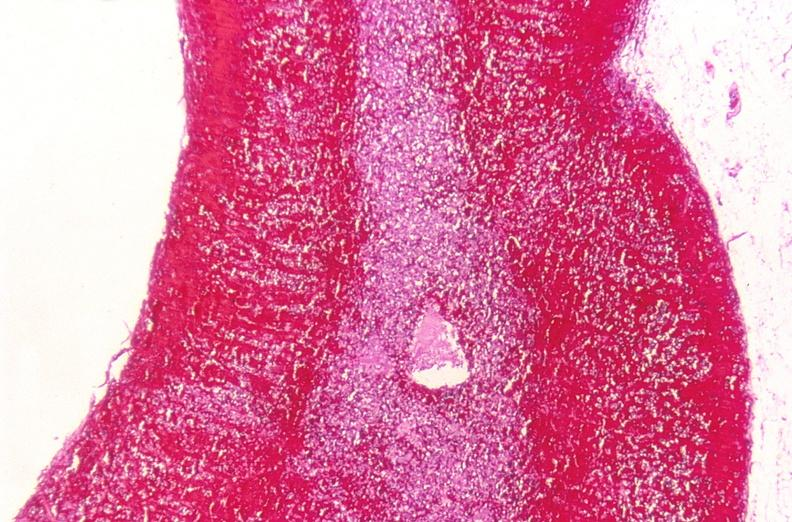does this image show adrenal gland, severe hemorrhage waterhouse-friderichsen syndrome?
Answer the question using a single word or phrase. Yes 